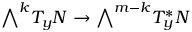<formula> <loc_0><loc_0><loc_500><loc_500>{ \bigwedge } ^ { k } T _ { y } N \to { \bigwedge } ^ { m - k } T _ { y } ^ { * } N</formula> 